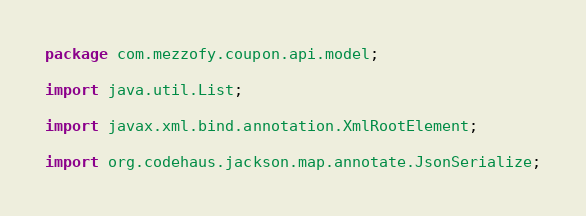Convert code to text. <code><loc_0><loc_0><loc_500><loc_500><_Java_>package com.mezzofy.coupon.api.model;

import java.util.List;

import javax.xml.bind.annotation.XmlRootElement;

import org.codehaus.jackson.map.annotate.JsonSerialize;
</code> 